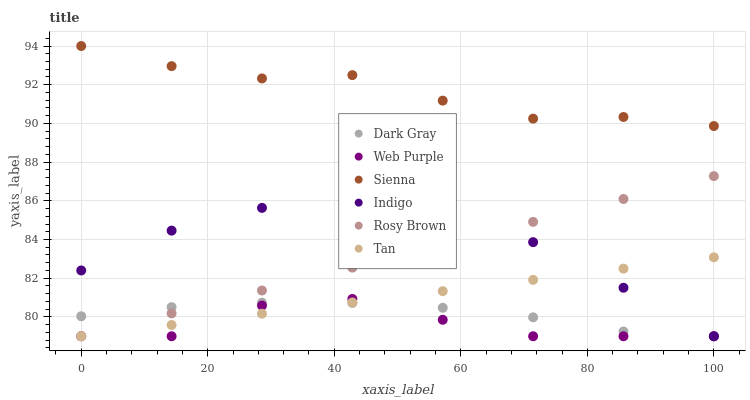Does Web Purple have the minimum area under the curve?
Answer yes or no. Yes. Does Sienna have the maximum area under the curve?
Answer yes or no. Yes. Does Indigo have the minimum area under the curve?
Answer yes or no. No. Does Indigo have the maximum area under the curve?
Answer yes or no. No. Is Tan the smoothest?
Answer yes or no. Yes. Is Web Purple the roughest?
Answer yes or no. Yes. Is Indigo the smoothest?
Answer yes or no. No. Is Indigo the roughest?
Answer yes or no. No. Does Indigo have the lowest value?
Answer yes or no. Yes. Does Sienna have the highest value?
Answer yes or no. Yes. Does Indigo have the highest value?
Answer yes or no. No. Is Tan less than Sienna?
Answer yes or no. Yes. Is Sienna greater than Rosy Brown?
Answer yes or no. Yes. Does Indigo intersect Web Purple?
Answer yes or no. Yes. Is Indigo less than Web Purple?
Answer yes or no. No. Is Indigo greater than Web Purple?
Answer yes or no. No. Does Tan intersect Sienna?
Answer yes or no. No. 